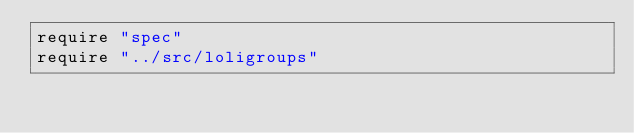<code> <loc_0><loc_0><loc_500><loc_500><_Crystal_>require "spec"
require "../src/loligroups"
</code> 